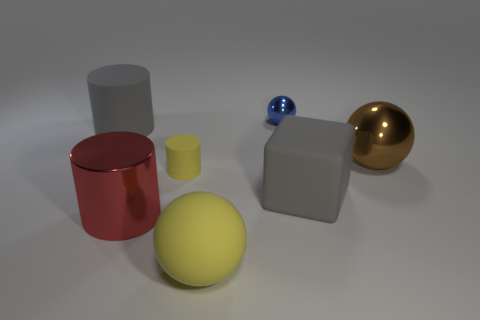Is the shape of the blue metal object the same as the big red metallic thing?
Offer a terse response. No. Do the ball in front of the brown metal thing and the small cylinder have the same color?
Your response must be concise. Yes. How many objects are big brown metallic balls or big rubber things behind the large yellow object?
Make the answer very short. 3. What is the material of the object that is on the left side of the brown metallic ball and to the right of the tiny metallic object?
Your response must be concise. Rubber. There is a small object that is behind the big brown metallic object; what material is it?
Give a very brief answer. Metal. What is the color of the cylinder that is made of the same material as the blue thing?
Your response must be concise. Red. Is the shape of the brown metallic object the same as the small thing behind the brown shiny sphere?
Provide a succinct answer. Yes. Are there any large gray objects behind the brown metallic ball?
Ensure brevity in your answer.  Yes. There is a cylinder that is the same color as the rubber cube; what is its material?
Provide a short and direct response. Rubber. Does the gray cylinder have the same size as the gray matte thing right of the big rubber cylinder?
Provide a succinct answer. Yes. 